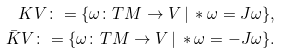<formula> <loc_0><loc_0><loc_500><loc_500>K V \colon = \{ \omega \colon T M \to V \, | \, * \omega = J \omega \} , \\ \bar { K } V \colon = \{ \omega \colon T M \to V \, | \, * \omega = - J \omega \} . \\</formula> 